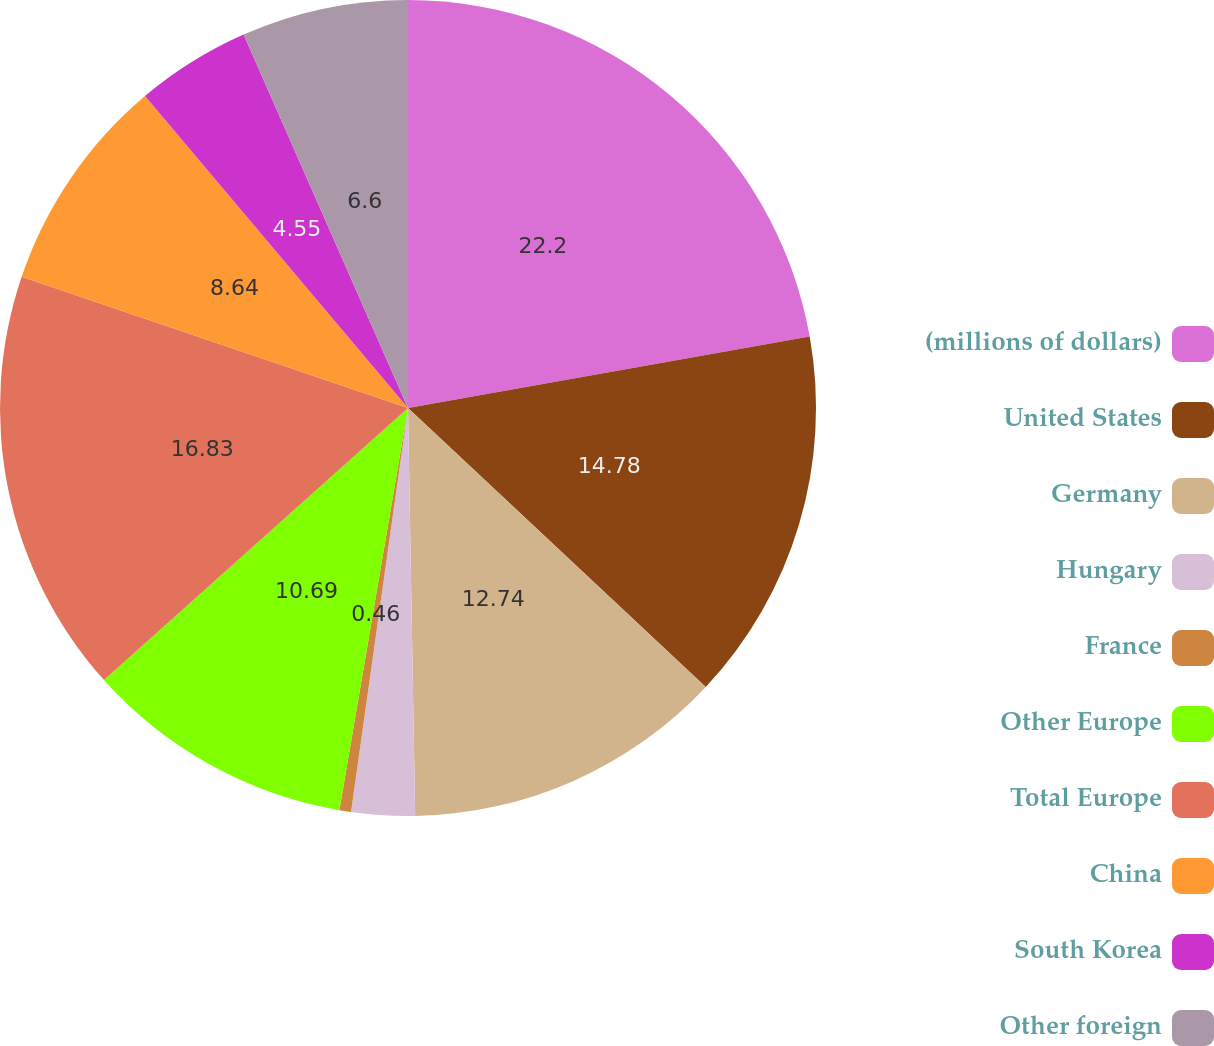Convert chart. <chart><loc_0><loc_0><loc_500><loc_500><pie_chart><fcel>(millions of dollars)<fcel>United States<fcel>Germany<fcel>Hungary<fcel>France<fcel>Other Europe<fcel>Total Europe<fcel>China<fcel>South Korea<fcel>Other foreign<nl><fcel>22.2%<fcel>14.78%<fcel>12.74%<fcel>2.51%<fcel>0.46%<fcel>10.69%<fcel>16.83%<fcel>8.64%<fcel>4.55%<fcel>6.6%<nl></chart> 